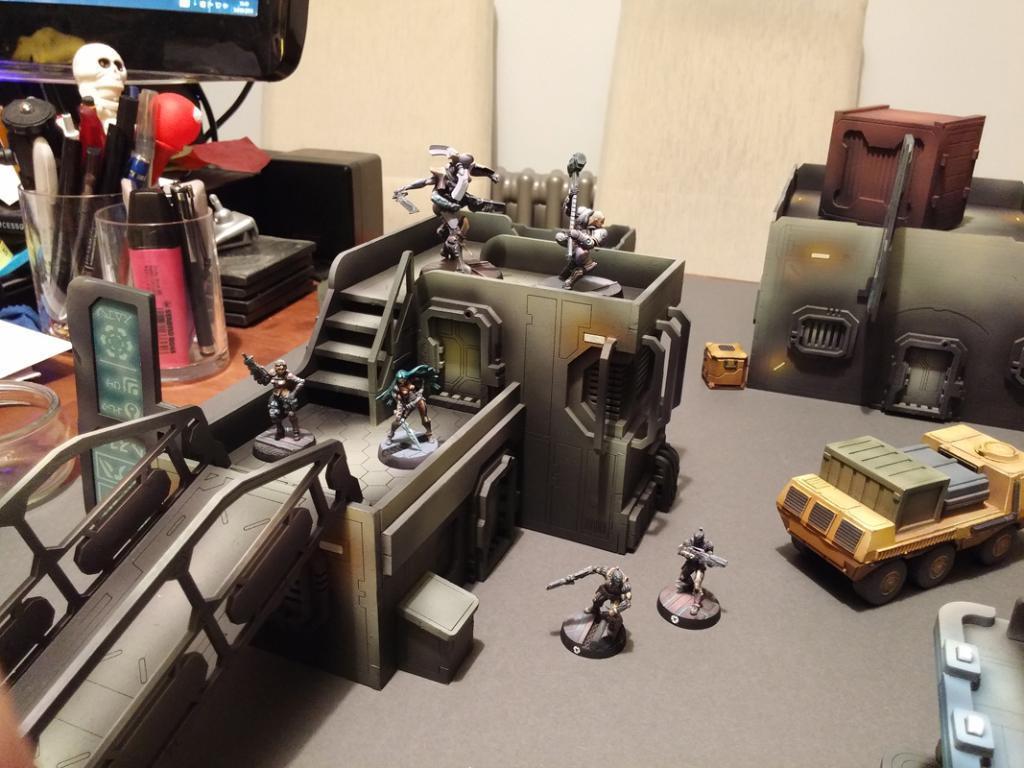How would you summarize this image in a sentence or two? In the picture we can see a house floor on it, we can see some toy vehicles and men and some constructions and behind it, we can see some wooden desk on it we can see some pens in the glass and something placed beside it. 